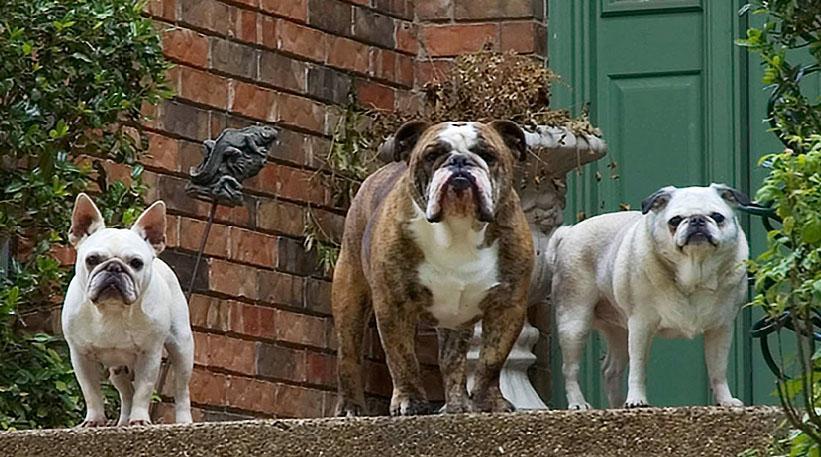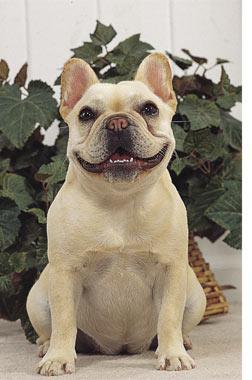The first image is the image on the left, the second image is the image on the right. For the images displayed, is the sentence "There is one dog lying on its stomach in the image on the right." factually correct? Answer yes or no. No. 